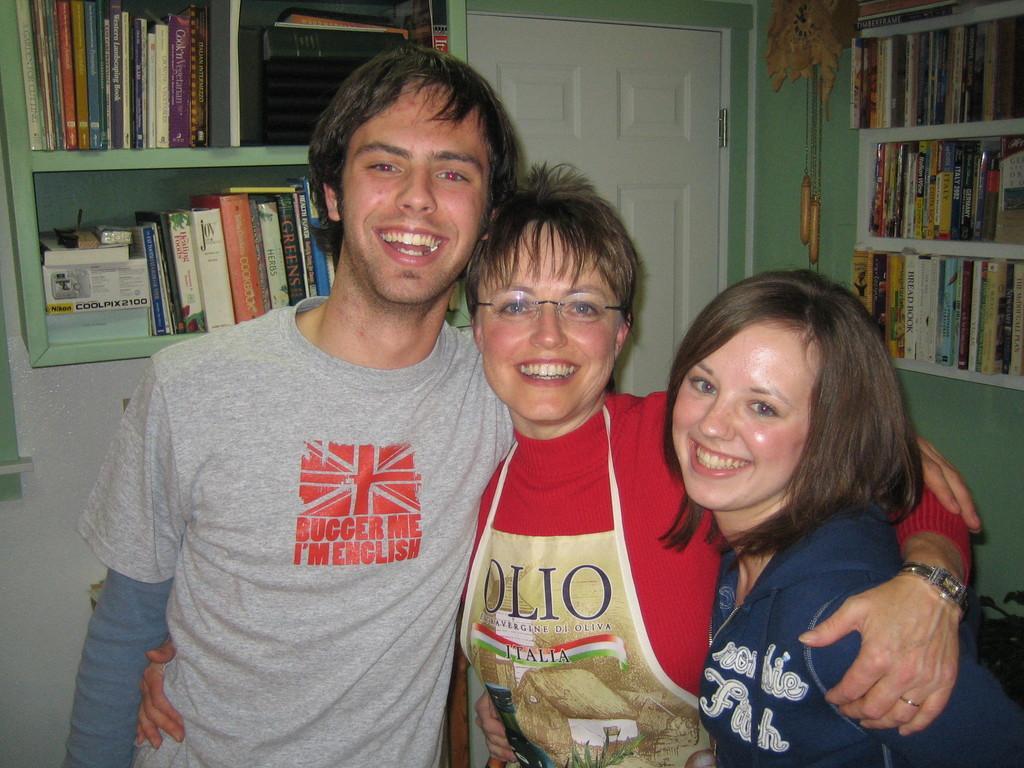Describe this image in one or two sentences. In the image we can see there are people standing and a woman is wearing an apron. Behind there are books kept in shelves. 